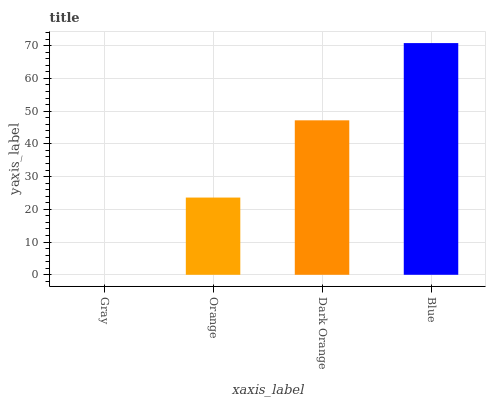Is Gray the minimum?
Answer yes or no. Yes. Is Blue the maximum?
Answer yes or no. Yes. Is Orange the minimum?
Answer yes or no. No. Is Orange the maximum?
Answer yes or no. No. Is Orange greater than Gray?
Answer yes or no. Yes. Is Gray less than Orange?
Answer yes or no. Yes. Is Gray greater than Orange?
Answer yes or no. No. Is Orange less than Gray?
Answer yes or no. No. Is Dark Orange the high median?
Answer yes or no. Yes. Is Orange the low median?
Answer yes or no. Yes. Is Gray the high median?
Answer yes or no. No. Is Gray the low median?
Answer yes or no. No. 